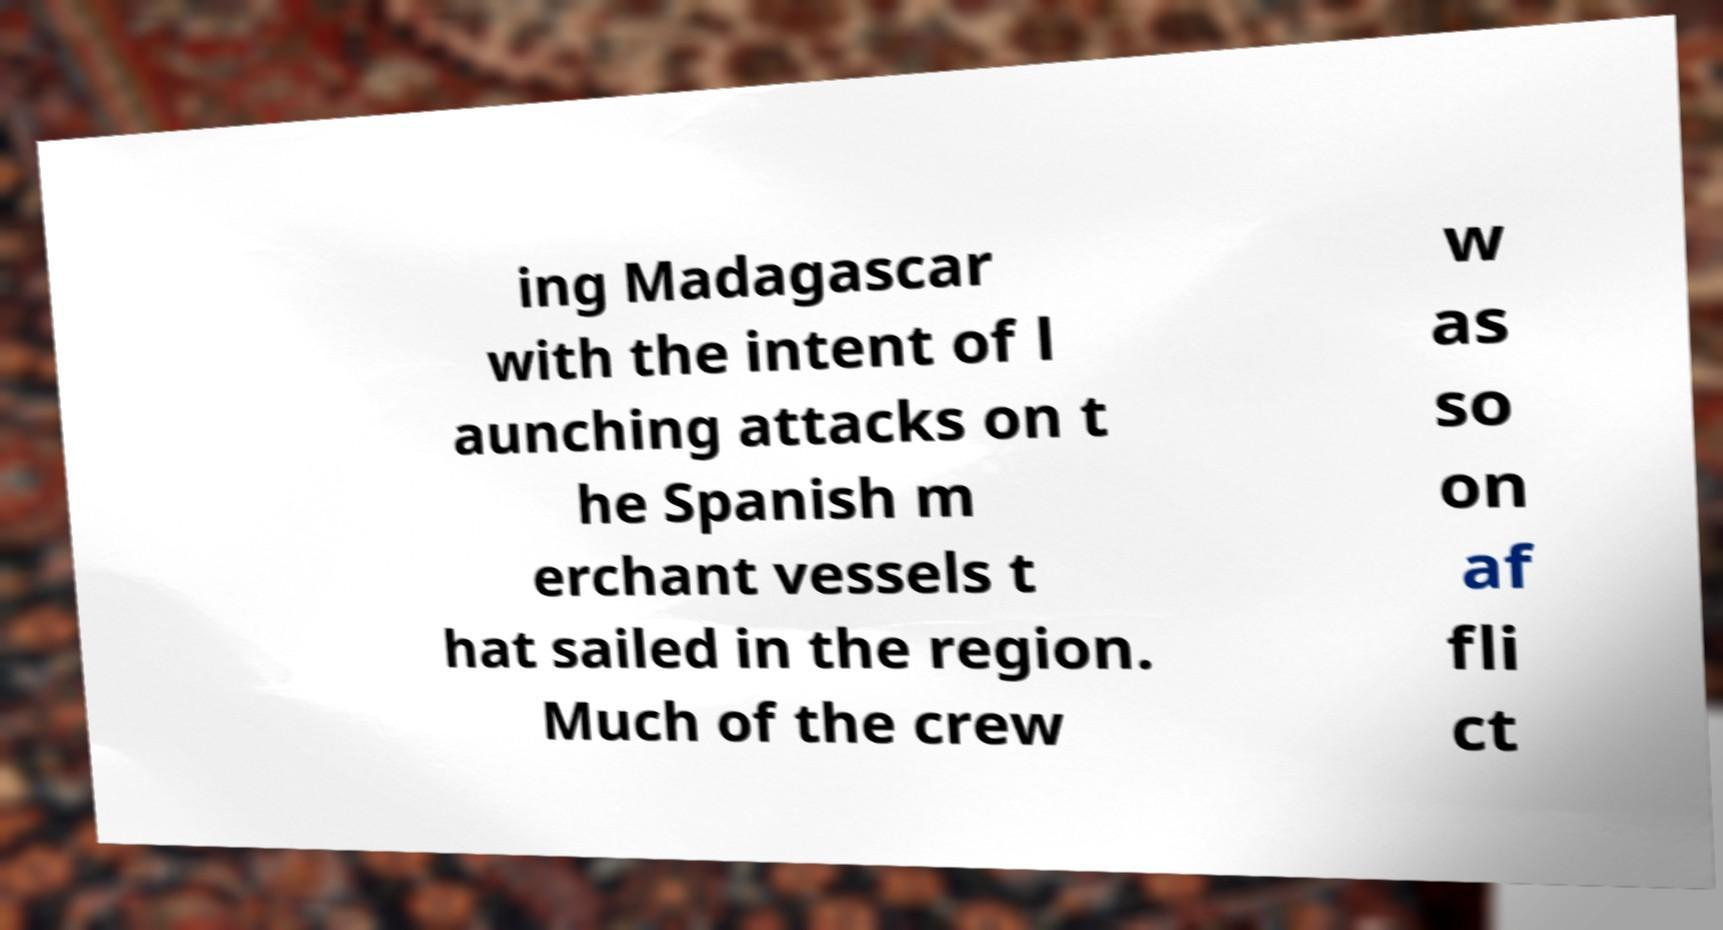For documentation purposes, I need the text within this image transcribed. Could you provide that? ing Madagascar with the intent of l aunching attacks on t he Spanish m erchant vessels t hat sailed in the region. Much of the crew w as so on af fli ct 